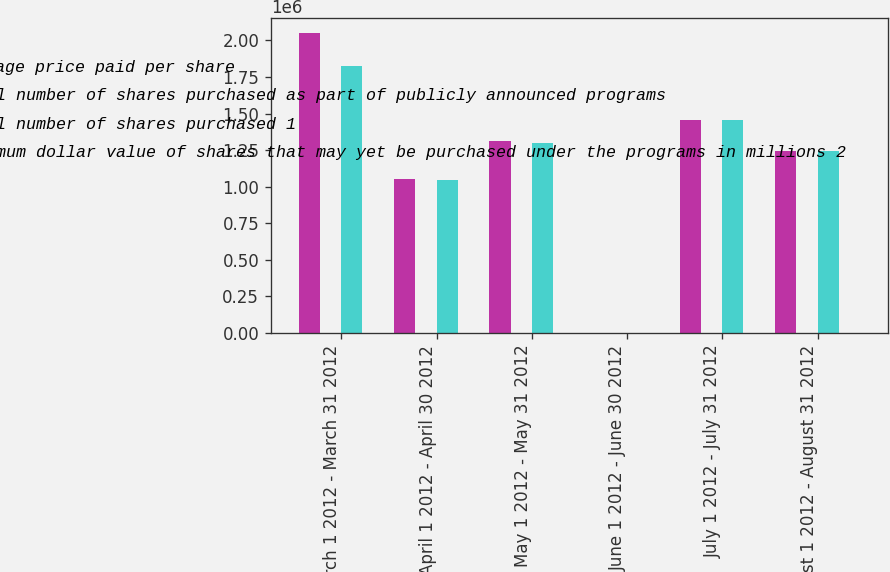Convert chart. <chart><loc_0><loc_0><loc_500><loc_500><stacked_bar_chart><ecel><fcel>March 1 2012 - March 31 2012<fcel>April 1 2012 - April 30 2012<fcel>May 1 2012 - May 31 2012<fcel>June 1 2012 - June 30 2012<fcel>July 1 2012 - July 31 2012<fcel>August 1 2012 - August 31 2012<nl><fcel>Average price paid per share<fcel>2.049e+06<fcel>1.05317e+06<fcel>1.31384e+06<fcel>149.2<fcel>1.45639e+06<fcel>1.24483e+06<nl><fcel>Total number of shares purchased as part of publicly announced programs<fcel>27.43<fcel>28.41<fcel>25.69<fcel>24.46<fcel>25.64<fcel>25.81<nl><fcel>Total number of shares purchased 1<fcel>1.82374e+06<fcel>1.04376e+06<fcel>1.30249e+06<fcel>149.2<fcel>1.4561e+06<fcel>1.2427e+06<nl><fcel>Maximum dollar value of shares that may yet be purchased under the programs in millions 2<fcel>50<fcel>20.4<fcel>186.9<fcel>111.5<fcel>74.2<fcel>42.1<nl></chart> 